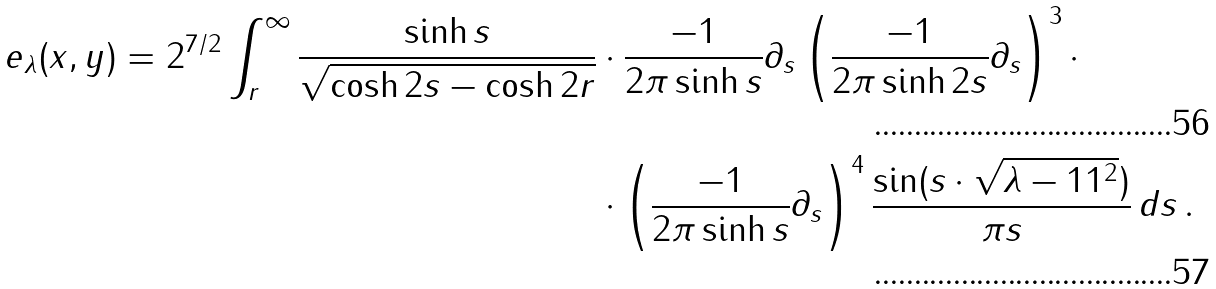Convert formula to latex. <formula><loc_0><loc_0><loc_500><loc_500>e _ { \lambda } ( x , y ) = 2 ^ { 7 / 2 } \int _ { r } ^ { \infty } \frac { \sinh s } { \sqrt { \cosh 2 s - \cosh 2 r } } & \cdot \frac { - 1 } { 2 \pi \sinh s } \partial _ { s } \left ( \frac { - 1 } { 2 \pi \sinh 2 s } \partial _ { s } \right ) ^ { 3 } \cdot \\ & \cdot \left ( \frac { - 1 } { 2 \pi \sinh s } \partial _ { s } \right ) ^ { 4 } \frac { \sin ( s \cdot \sqrt { \lambda - 1 1 ^ { 2 } } ) } { \pi s } \, d s \, .</formula> 